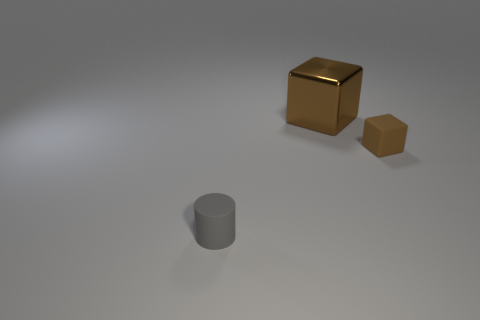Add 3 big brown spheres. How many objects exist? 6 Subtract all cylinders. How many objects are left? 2 Subtract all gray things. Subtract all large cyan metallic cubes. How many objects are left? 2 Add 3 matte cubes. How many matte cubes are left? 4 Add 2 small brown cubes. How many small brown cubes exist? 3 Subtract 0 brown spheres. How many objects are left? 3 